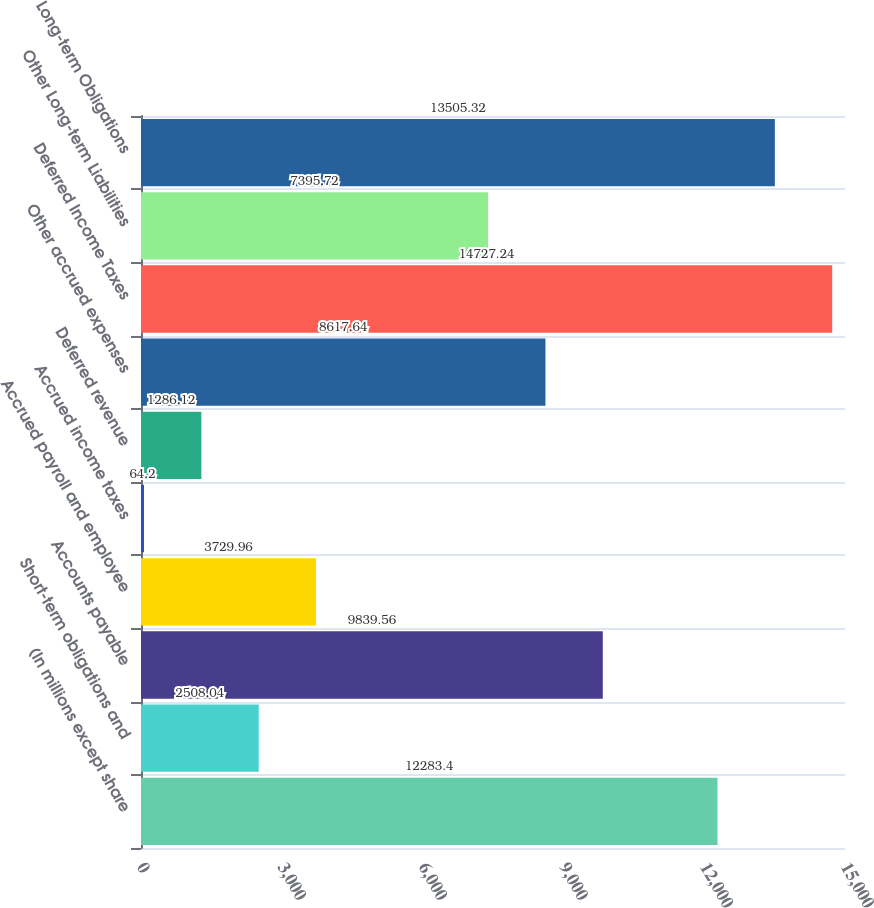Convert chart. <chart><loc_0><loc_0><loc_500><loc_500><bar_chart><fcel>(In millions except share<fcel>Short-term obligations and<fcel>Accounts payable<fcel>Accrued payroll and employee<fcel>Accrued income taxes<fcel>Deferred revenue<fcel>Other accrued expenses<fcel>Deferred Income Taxes<fcel>Other Long-term Liabilities<fcel>Long-term Obligations<nl><fcel>12283.4<fcel>2508.04<fcel>9839.56<fcel>3729.96<fcel>64.2<fcel>1286.12<fcel>8617.64<fcel>14727.2<fcel>7395.72<fcel>13505.3<nl></chart> 